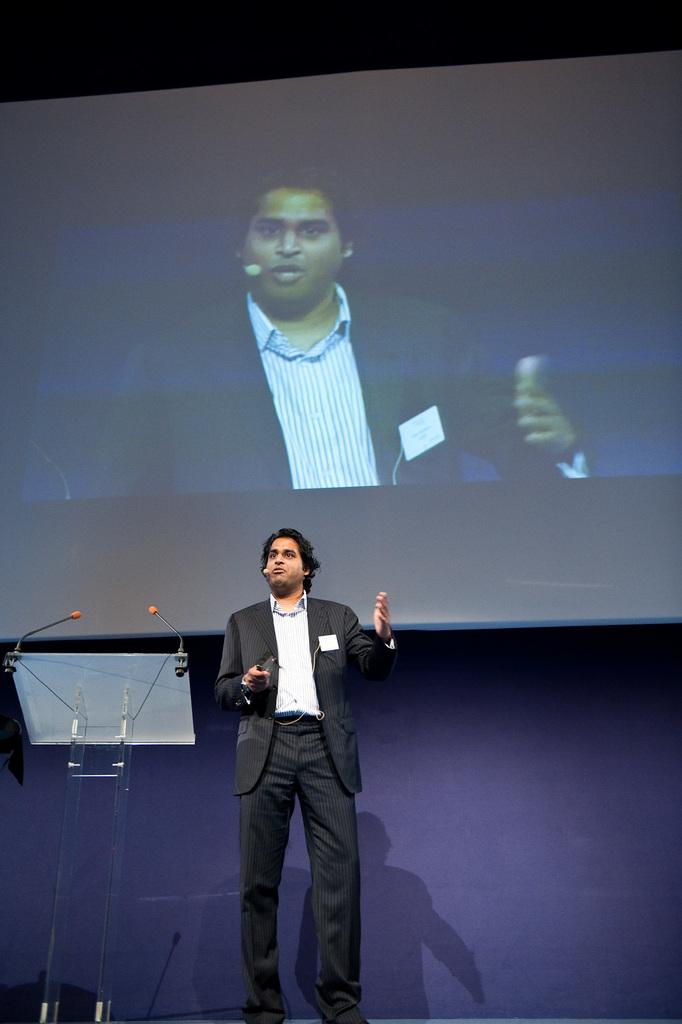What is the person in the image doing? The person is standing in front of the podium. What is on the podium? There are microphones on the podium. What is located at the top of the image? There is a screen at the top of the image. What can be seen on the screen? A person's image is displayed on the screen. What type of table is the person using to display their behavior in the image? There is no table present in the image, and the person's behavior is not mentioned or depicted. How does the queen interact with the person on the screen in the image? There is no queen present in the image, so it is not possible to determine how she might interact with the person on the screen. 